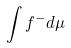<formula> <loc_0><loc_0><loc_500><loc_500>\int f ^ { - } d \mu</formula> 